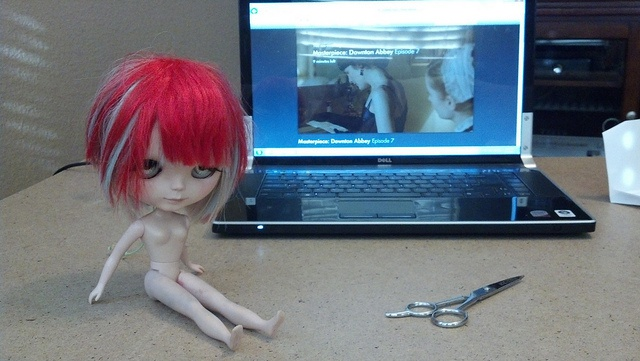Describe the objects in this image and their specific colors. I can see dining table in gray and darkgray tones, laptop in gray, blue, black, white, and navy tones, keyboard in gray, blue, and navy tones, people in gray, lightblue, blue, and navy tones, and people in gray, lightblue, and blue tones in this image. 